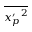<formula> <loc_0><loc_0><loc_500><loc_500>\overline { { { x _ { p } ^ { \prime } } ^ { 2 } } }</formula> 